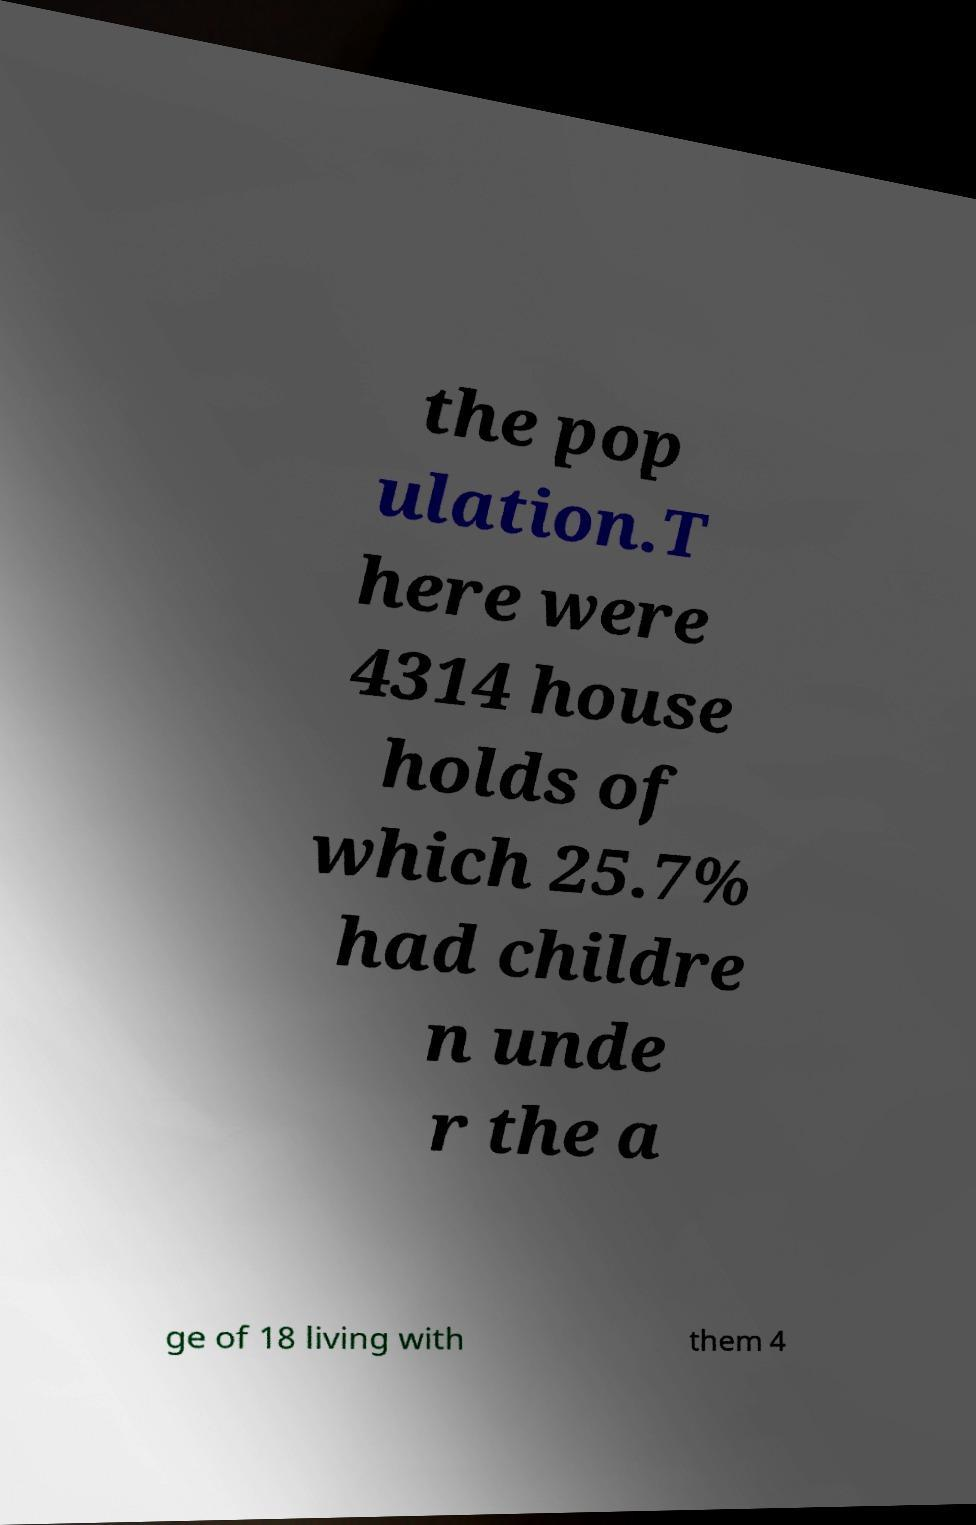Please read and relay the text visible in this image. What does it say? the pop ulation.T here were 4314 house holds of which 25.7% had childre n unde r the a ge of 18 living with them 4 